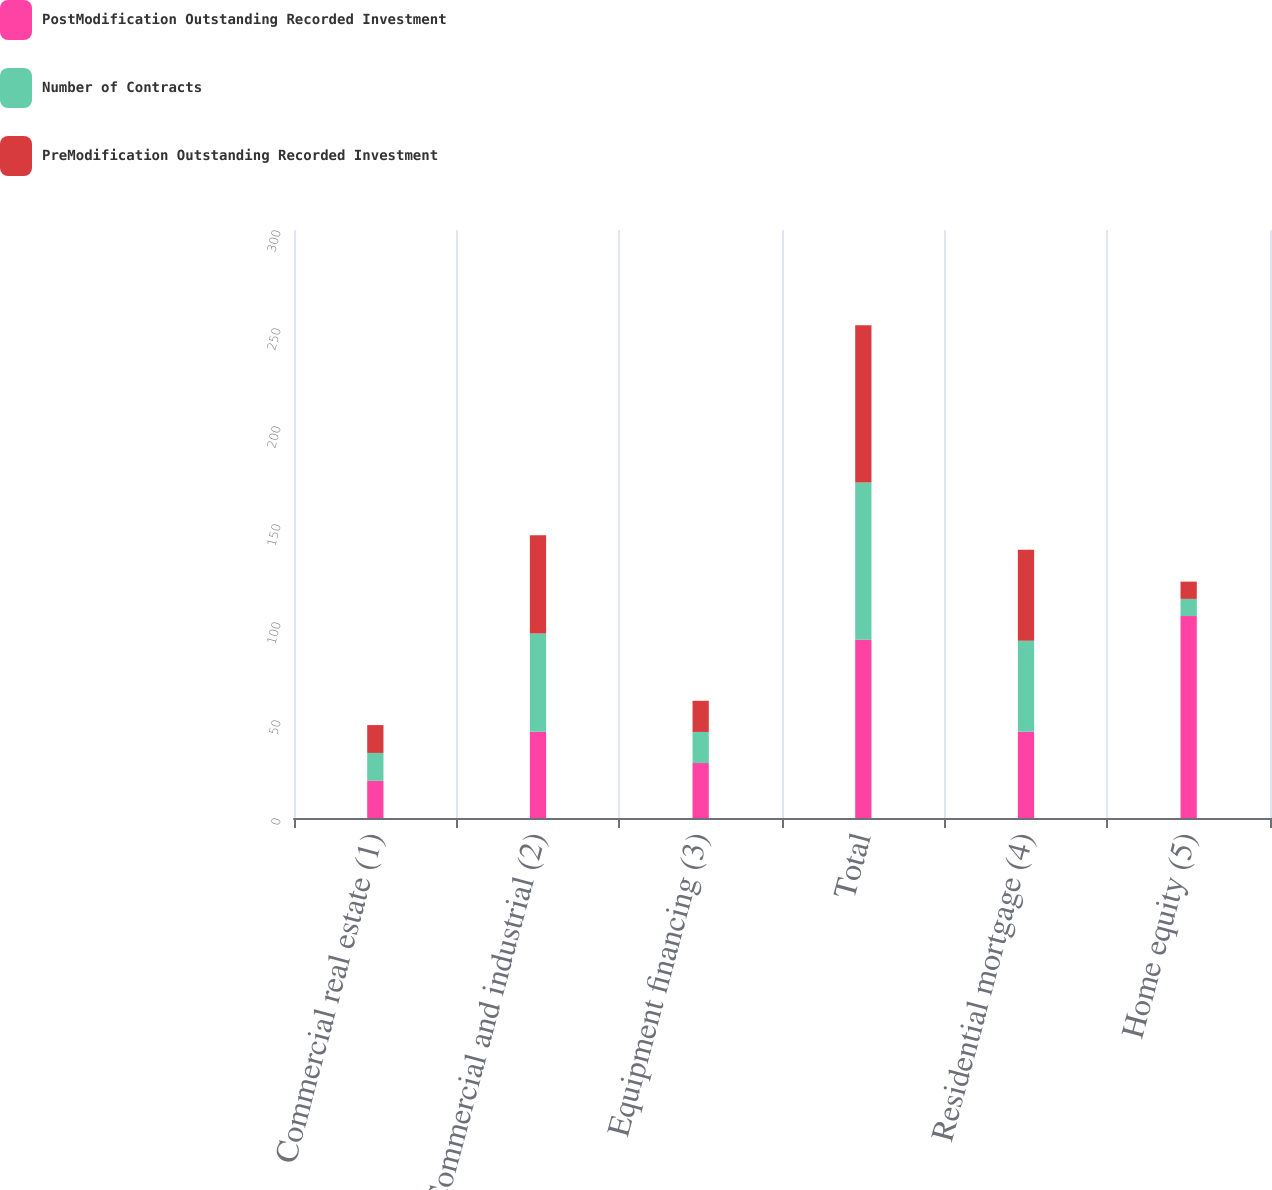<chart> <loc_0><loc_0><loc_500><loc_500><stacked_bar_chart><ecel><fcel>Commercial real estate (1)<fcel>Commercial and industrial (2)<fcel>Equipment financing (3)<fcel>Total<fcel>Residential mortgage (4)<fcel>Home equity (5)<nl><fcel>PostModification Outstanding Recorded Investment<fcel>19<fcel>44<fcel>28<fcel>91<fcel>44<fcel>103<nl><fcel>Number of Contracts<fcel>14.2<fcel>50.1<fcel>15.9<fcel>80.2<fcel>46.4<fcel>8.8<nl><fcel>PreModification Outstanding Recorded Investment<fcel>14.2<fcel>50.1<fcel>15.9<fcel>80.2<fcel>46.4<fcel>8.8<nl></chart> 